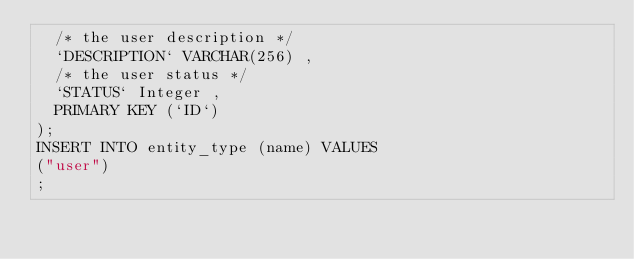Convert code to text. <code><loc_0><loc_0><loc_500><loc_500><_SQL_>  /* the user description */
  `DESCRIPTION` VARCHAR(256) ,
  /* the user status */
  `STATUS` Integer ,
  PRIMARY KEY (`ID`)
);
INSERT INTO entity_type (name) VALUES
("user")
;
</code> 